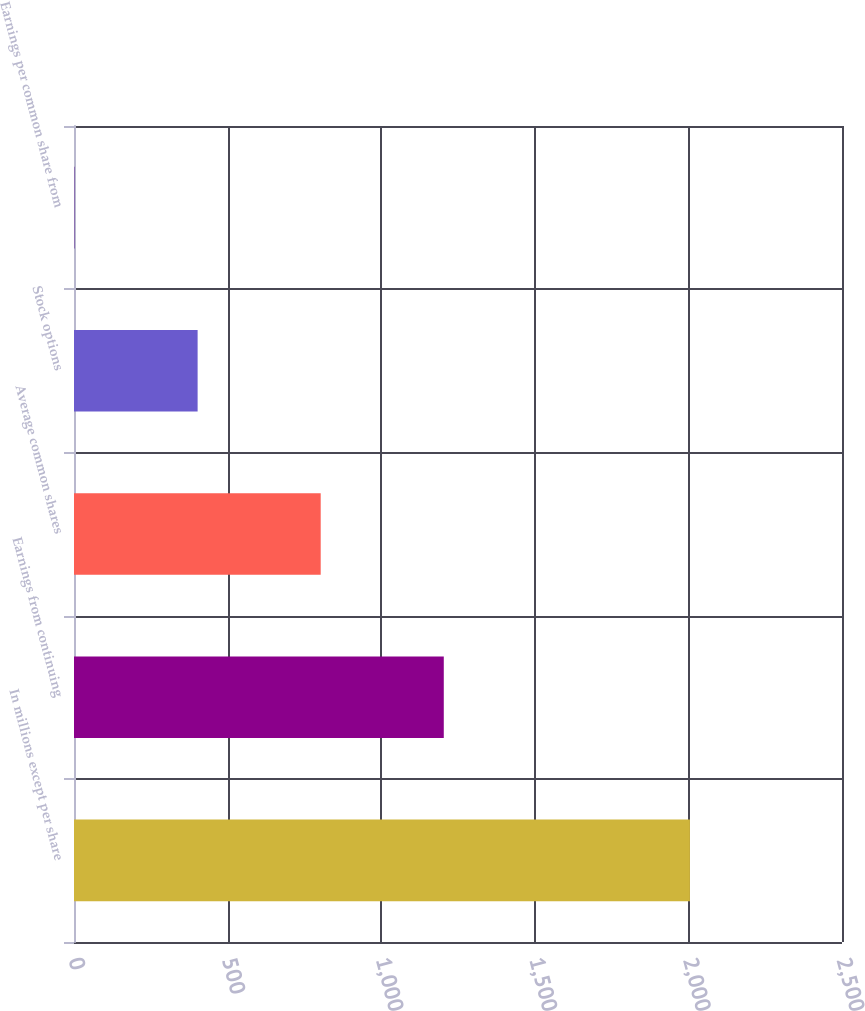<chart> <loc_0><loc_0><loc_500><loc_500><bar_chart><fcel>In millions except per share<fcel>Earnings from continuing<fcel>Average common shares<fcel>Stock options<fcel>Earnings per common share from<nl><fcel>2005<fcel>1203.72<fcel>803.06<fcel>402.4<fcel>1.74<nl></chart> 